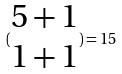Convert formula to latex. <formula><loc_0><loc_0><loc_500><loc_500>( \begin{matrix} 5 + 1 \\ 1 + 1 \end{matrix} ) = 1 5</formula> 